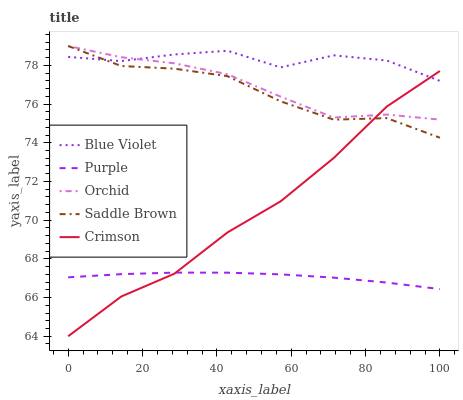Does Purple have the minimum area under the curve?
Answer yes or no. Yes. Does Blue Violet have the maximum area under the curve?
Answer yes or no. Yes. Does Crimson have the minimum area under the curve?
Answer yes or no. No. Does Crimson have the maximum area under the curve?
Answer yes or no. No. Is Purple the smoothest?
Answer yes or no. Yes. Is Blue Violet the roughest?
Answer yes or no. Yes. Is Crimson the smoothest?
Answer yes or no. No. Is Crimson the roughest?
Answer yes or no. No. Does Crimson have the lowest value?
Answer yes or no. Yes. Does Saddle Brown have the lowest value?
Answer yes or no. No. Does Orchid have the highest value?
Answer yes or no. Yes. Does Crimson have the highest value?
Answer yes or no. No. Is Purple less than Orchid?
Answer yes or no. Yes. Is Saddle Brown greater than Purple?
Answer yes or no. Yes. Does Orchid intersect Blue Violet?
Answer yes or no. Yes. Is Orchid less than Blue Violet?
Answer yes or no. No. Is Orchid greater than Blue Violet?
Answer yes or no. No. Does Purple intersect Orchid?
Answer yes or no. No. 